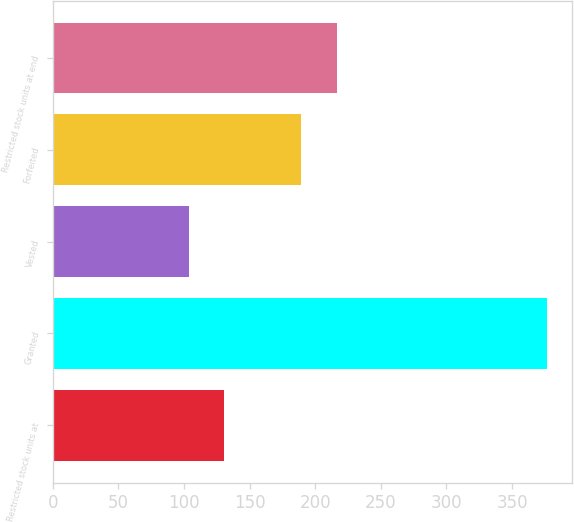Convert chart to OTSL. <chart><loc_0><loc_0><loc_500><loc_500><bar_chart><fcel>Restricted stock units at<fcel>Granted<fcel>Vested<fcel>Forfeited<fcel>Restricted stock units at end<nl><fcel>130.88<fcel>376.95<fcel>103.54<fcel>189.05<fcel>216.39<nl></chart> 